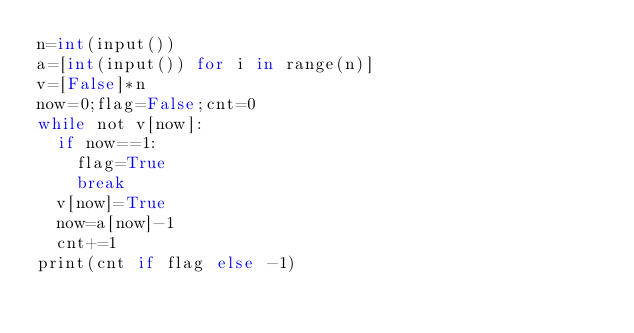Convert code to text. <code><loc_0><loc_0><loc_500><loc_500><_Cython_>n=int(input())
a=[int(input()) for i in range(n)]
v=[False]*n
now=0;flag=False;cnt=0
while not v[now]:
  if now==1:
    flag=True
    break
  v[now]=True
  now=a[now]-1
  cnt+=1
print(cnt if flag else -1)</code> 